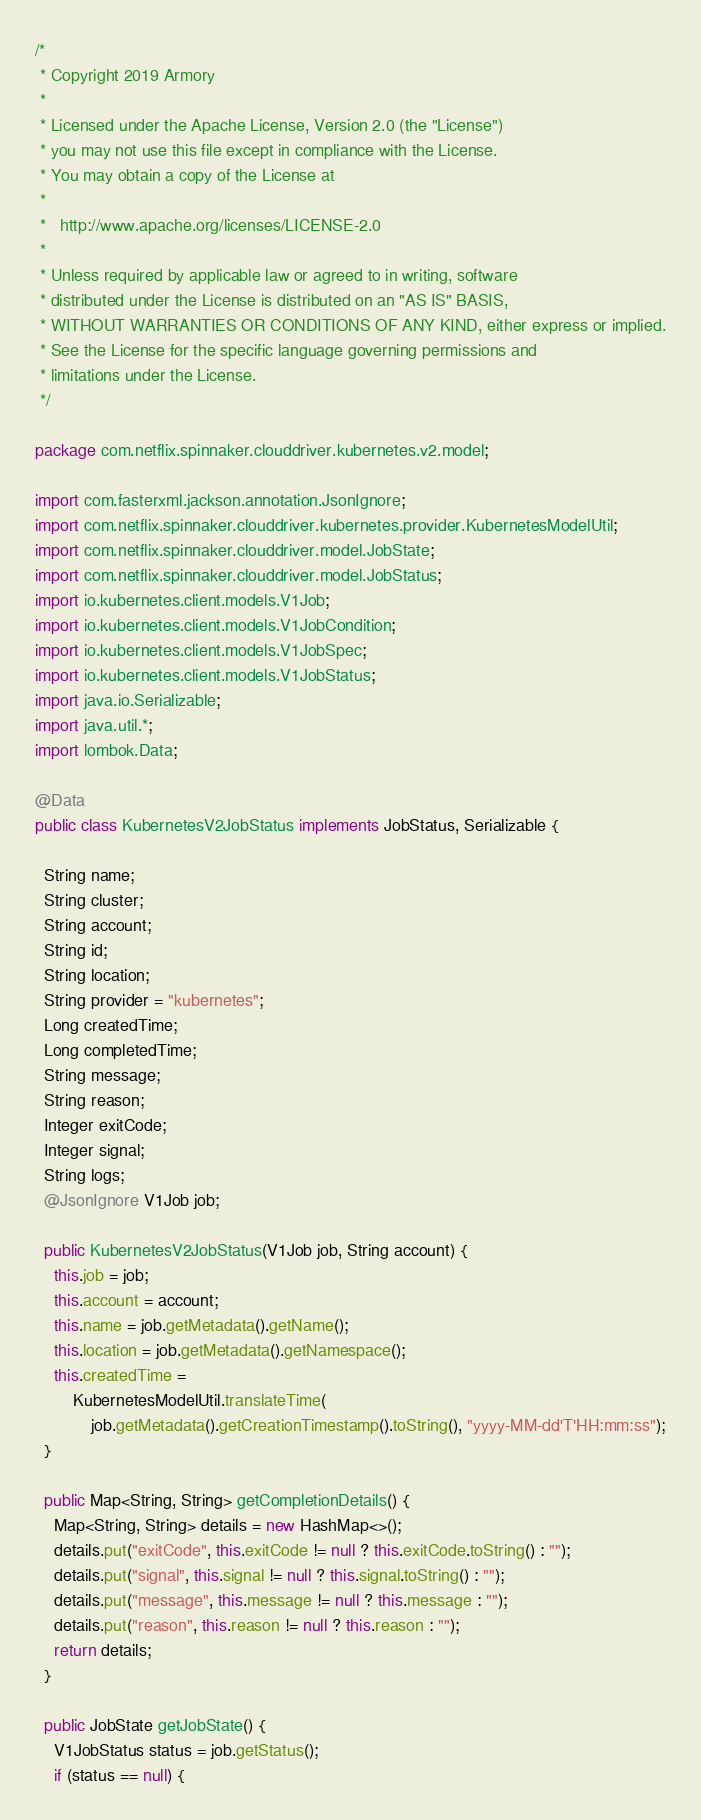Convert code to text. <code><loc_0><loc_0><loc_500><loc_500><_Java_>/*
 * Copyright 2019 Armory
 *
 * Licensed under the Apache License, Version 2.0 (the "License")
 * you may not use this file except in compliance with the License.
 * You may obtain a copy of the License at
 *
 *   http://www.apache.org/licenses/LICENSE-2.0
 *
 * Unless required by applicable law or agreed to in writing, software
 * distributed under the License is distributed on an "AS IS" BASIS,
 * WITHOUT WARRANTIES OR CONDITIONS OF ANY KIND, either express or implied.
 * See the License for the specific language governing permissions and
 * limitations under the License.
 */

package com.netflix.spinnaker.clouddriver.kubernetes.v2.model;

import com.fasterxml.jackson.annotation.JsonIgnore;
import com.netflix.spinnaker.clouddriver.kubernetes.provider.KubernetesModelUtil;
import com.netflix.spinnaker.clouddriver.model.JobState;
import com.netflix.spinnaker.clouddriver.model.JobStatus;
import io.kubernetes.client.models.V1Job;
import io.kubernetes.client.models.V1JobCondition;
import io.kubernetes.client.models.V1JobSpec;
import io.kubernetes.client.models.V1JobStatus;
import java.io.Serializable;
import java.util.*;
import lombok.Data;

@Data
public class KubernetesV2JobStatus implements JobStatus, Serializable {

  String name;
  String cluster;
  String account;
  String id;
  String location;
  String provider = "kubernetes";
  Long createdTime;
  Long completedTime;
  String message;
  String reason;
  Integer exitCode;
  Integer signal;
  String logs;
  @JsonIgnore V1Job job;

  public KubernetesV2JobStatus(V1Job job, String account) {
    this.job = job;
    this.account = account;
    this.name = job.getMetadata().getName();
    this.location = job.getMetadata().getNamespace();
    this.createdTime =
        KubernetesModelUtil.translateTime(
            job.getMetadata().getCreationTimestamp().toString(), "yyyy-MM-dd'T'HH:mm:ss");
  }

  public Map<String, String> getCompletionDetails() {
    Map<String, String> details = new HashMap<>();
    details.put("exitCode", this.exitCode != null ? this.exitCode.toString() : "");
    details.put("signal", this.signal != null ? this.signal.toString() : "");
    details.put("message", this.message != null ? this.message : "");
    details.put("reason", this.reason != null ? this.reason : "");
    return details;
  }

  public JobState getJobState() {
    V1JobStatus status = job.getStatus();
    if (status == null) {</code> 